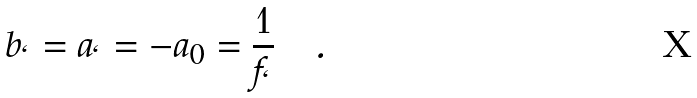Convert formula to latex. <formula><loc_0><loc_0><loc_500><loc_500>b _ { \ell } = a _ { \ell } = - a _ { 0 } = \frac { 1 } { f _ { \ell } } \quad .</formula> 